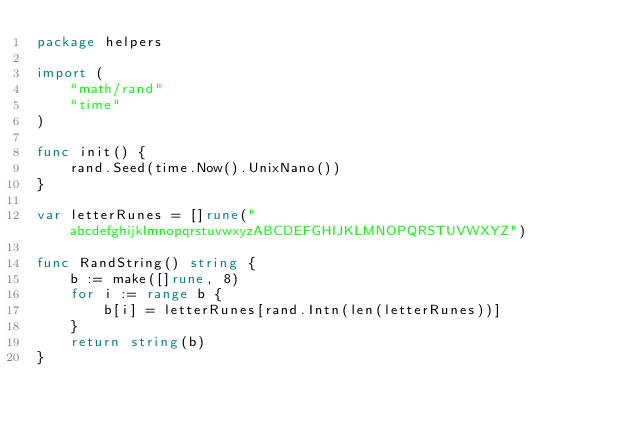<code> <loc_0><loc_0><loc_500><loc_500><_Go_>package helpers

import (
	"math/rand"
	"time"
)

func init() {
	rand.Seed(time.Now().UnixNano())
}

var letterRunes = []rune("abcdefghijklmnopqrstuvwxyzABCDEFGHIJKLMNOPQRSTUVWXYZ")

func RandString() string {
	b := make([]rune, 8)
	for i := range b {
		b[i] = letterRunes[rand.Intn(len(letterRunes))]
	}
	return string(b)
}
</code> 